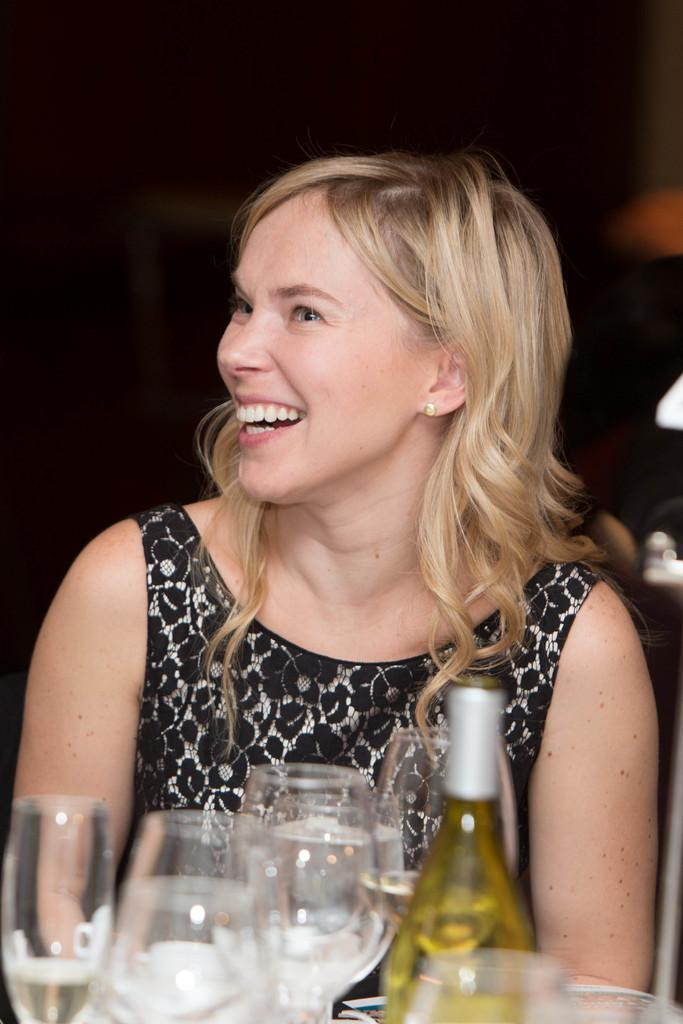What is the person in the image doing? The person is sitting. What is the person's facial expression in the image? The person is smiling. What color is the dress the person is wearing? The person is wearing a black dress. What can be seen near the person in the image? There are glasses visible and a bottle present. Are there any men interacting with the snake in the quicksand in the image? There is no mention of men, snakes, or quicksand in the provided facts, so these elements are not present in the image. 